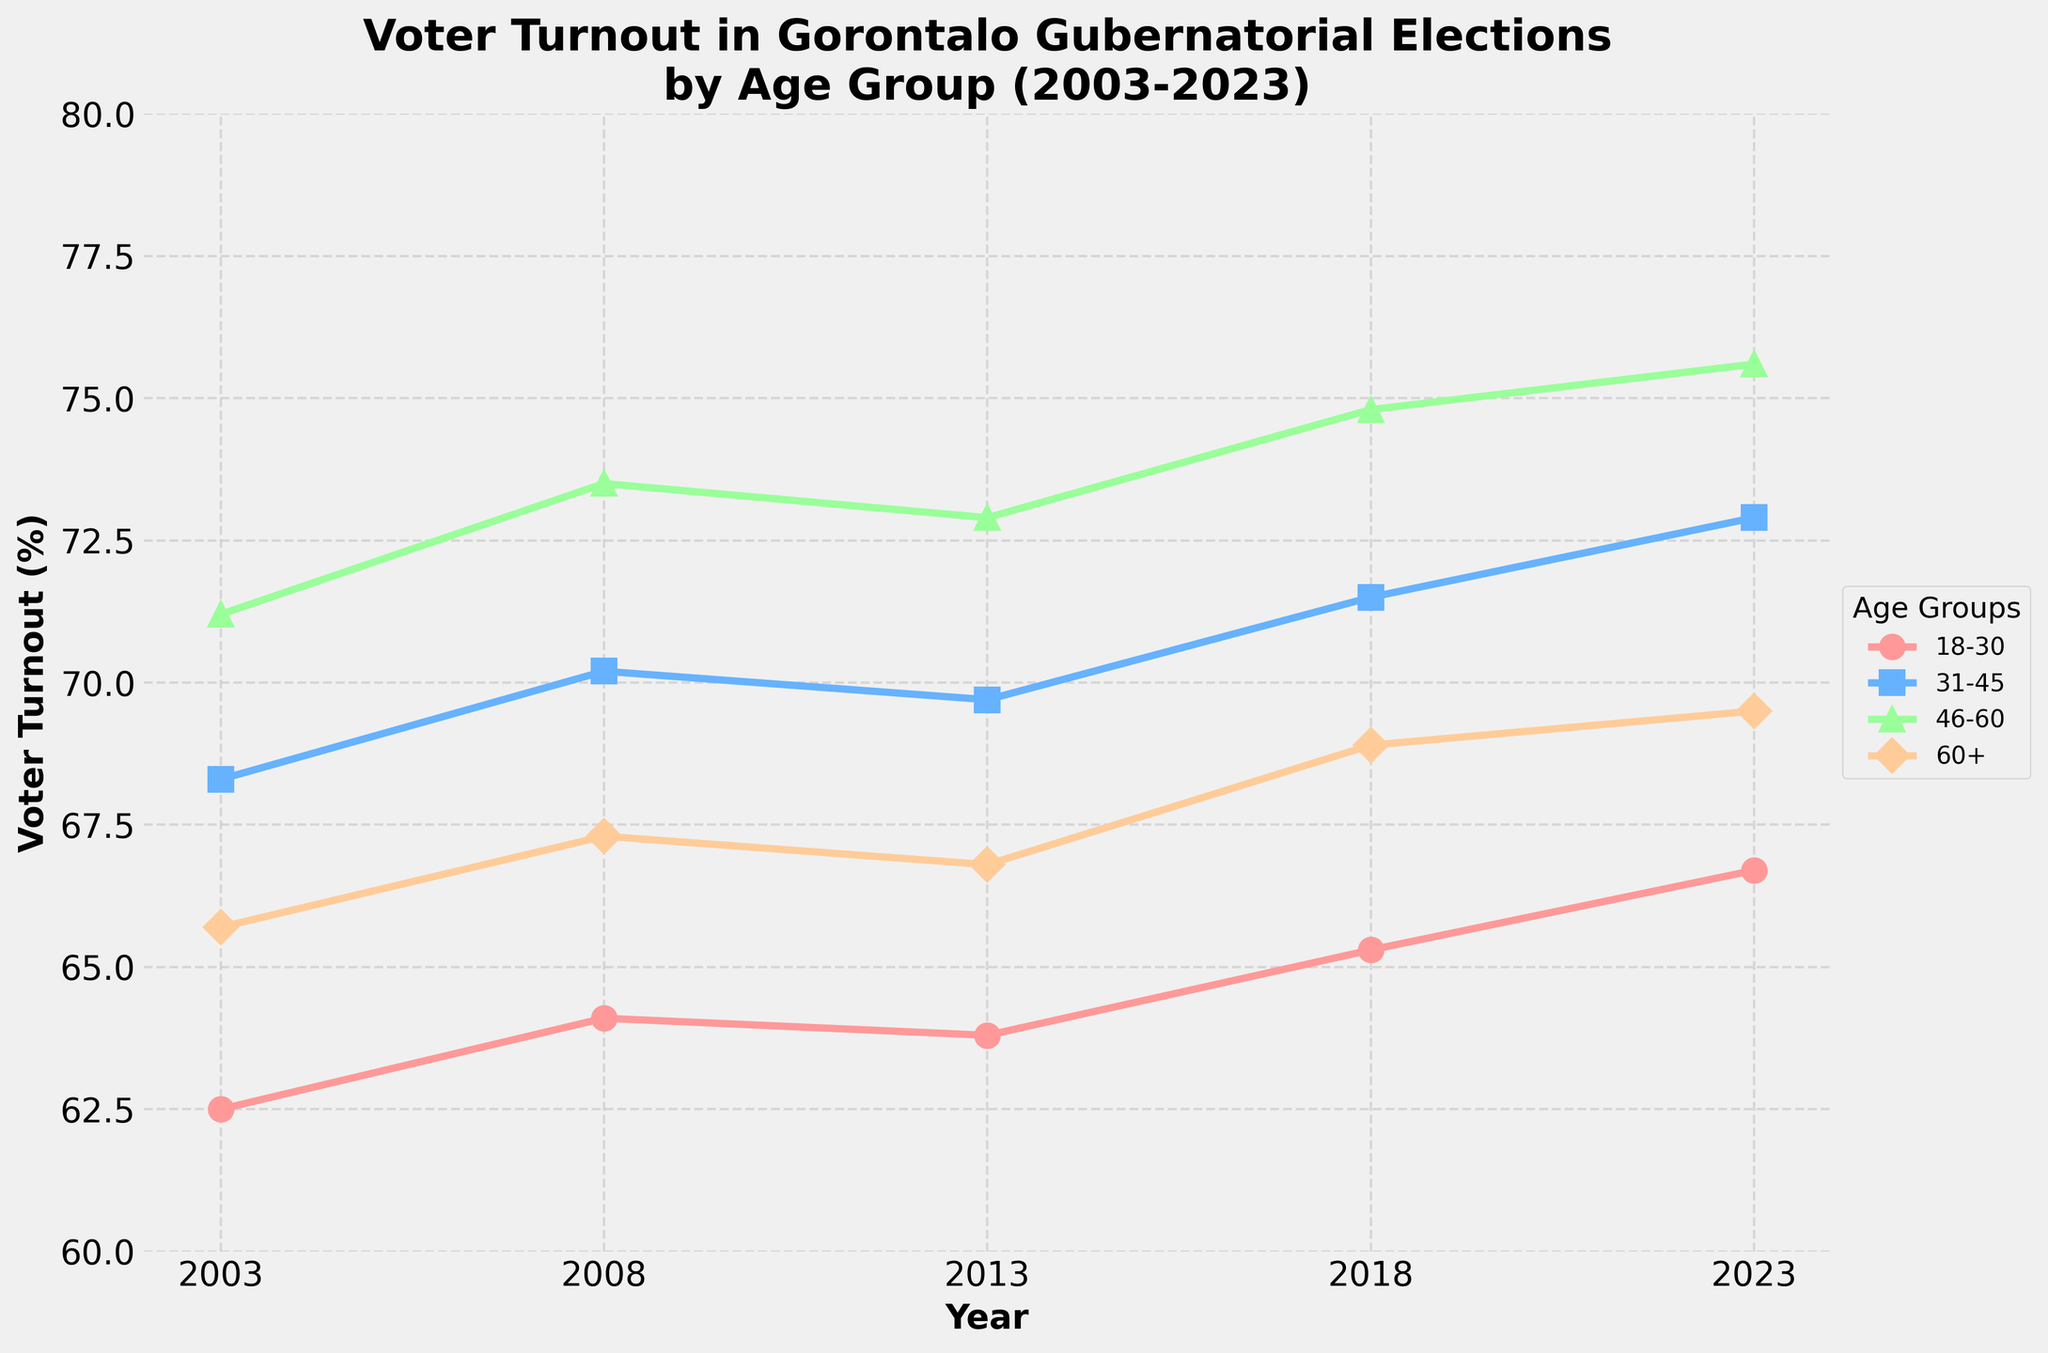What's the voter turnout trend for the 18-30 age group over the years? The turnout for the 18-30 age group increases slightly from 62.5% in 2003, to 64.1% in 2008, then slightly decreases to 63.8% in 2013, and finally increases again to 65.3% in 2018 and 66.7% in 2023.
Answer: Increasing but with minor fluctuations Which age group had the highest turnout in 2023? In 2023, the 46-60 age group had the highest turnout at 75.6%, compared to 66.7% for 18-30, 72.9% for 31-45, and 69.5% for 60+.
Answer: 46-60 How did the voter turnout for the 60+ age group change between 2003 and 2023? The turnout for the 60+ age group was 65.7% in 2003 and increased to 69.5% in 2023. Over the 20 years, there was a consistent increase.
Answer: Increased by 3.8% Compare the voter turnout of the 31-45 and 46-60 age groups in 2018. In 2018, the turnout for the 31-45 age group was 71.5%, while for the 46-60 age group, it was 74.8%. The 46-60 age group had a higher turnout by 3.3%.
Answer: 46-60 had higher turnout by 3.3% What are the average voter turnouts for the 46-60 age group over the 20 years? The voter turnouts for the 46-60 age group are: 71.2%, 73.5%, 72.9%, 74.8%, and 75.6%. The average turnout is (71.2 + 73.5 + 72.9 + 74.8 + 75.6) / 5 = 73.6%.
Answer: 73.6% In which year did the 18-30 age group have the lowest turnout? The 18-30 age group had the lowest turnout in 2003, with a percentage of 62.5%.
Answer: 2003 Did any age group experience a decrease in voter turnout between two consecutive election years? The 18-30 age group experienced a decrease from 64.1% in 2008 to 63.8% in 2013.
Answer: 18-30 between 2008 and 2013 How did the voter turnout for the 31-45 age group vary from 2003 to 2023? The turnout for the 31-45 age group increased from 68.3% in 2003 to 72.9% in 2023, with minor fluctuations in between.
Answer: Increased by 4.6% Which age group showed the most significant increase in voter turnout from 2003 to 2023? The 46-60 age group showed the most significant increase, from 71.2% in 2003 to 75.6% in 2023, an increase of 4.4%.
Answer: 46-60 age group 